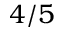<formula> <loc_0><loc_0><loc_500><loc_500>4 / 5</formula> 